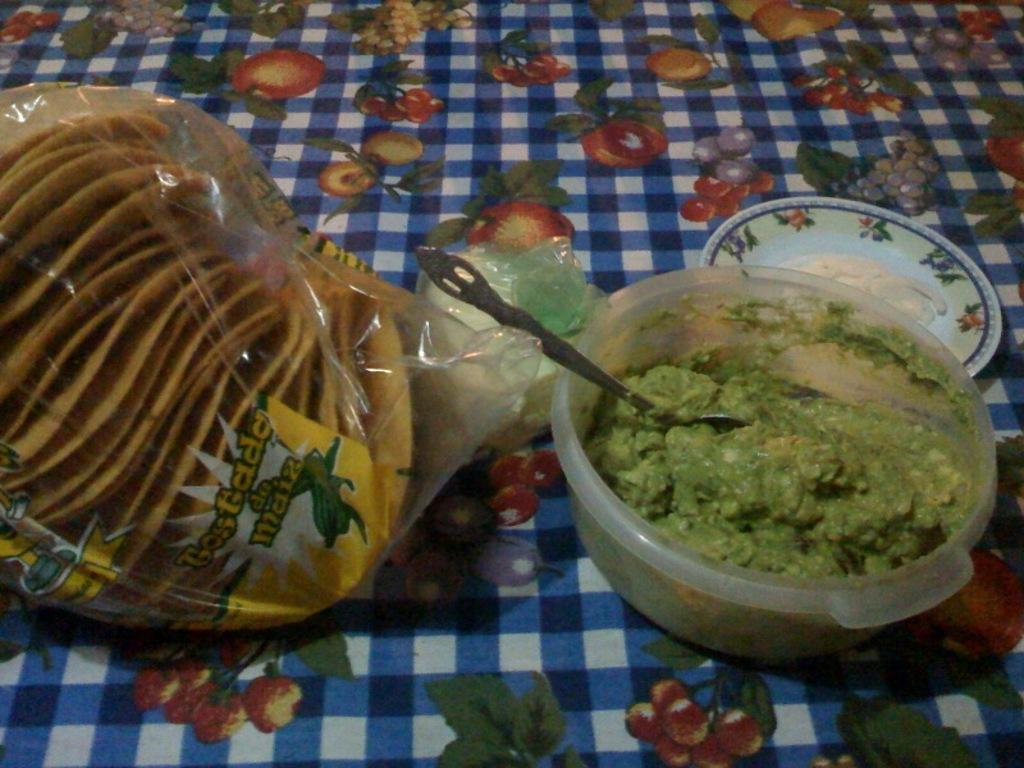What type of food is in the box in the image? The food in the box is green in color. Can you describe the food in the cover? The food in the cover is also green in color. What colors are present on the cloth under the cover? The cloth has white, blue, and red colors. What type of music is playing in the background of the image? There is no music playing in the background of the image. How does the green food make you feel when you look at the image? The image does not convey any feelings or emotions, as it only shows food in a box and cover on a cloth. 